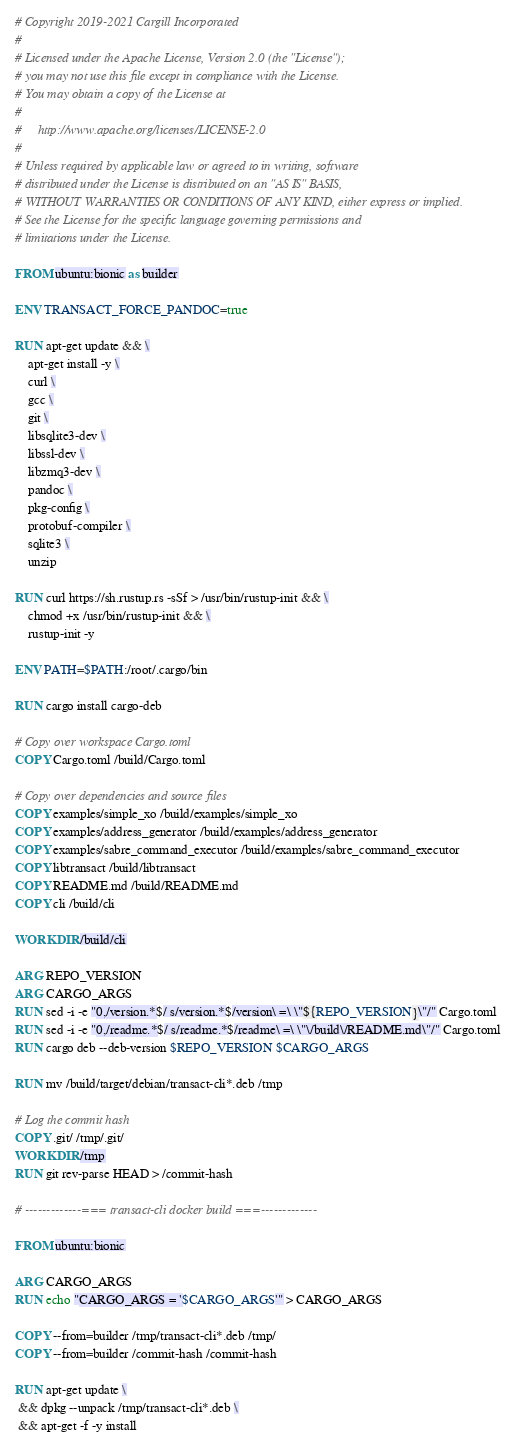<code> <loc_0><loc_0><loc_500><loc_500><_Dockerfile_># Copyright 2019-2021 Cargill Incorporated
#
# Licensed under the Apache License, Version 2.0 (the "License");
# you may not use this file except in compliance with the License.
# You may obtain a copy of the License at
#
#     http://www.apache.org/licenses/LICENSE-2.0
#
# Unless required by applicable law or agreed to in writing, software
# distributed under the License is distributed on an "AS IS" BASIS,
# WITHOUT WARRANTIES OR CONDITIONS OF ANY KIND, either express or implied.
# See the License for the specific language governing permissions and
# limitations under the License.

FROM ubuntu:bionic as builder

ENV TRANSACT_FORCE_PANDOC=true

RUN apt-get update && \
    apt-get install -y \
    curl \
    gcc \
    git \
    libsqlite3-dev \
    libssl-dev \
    libzmq3-dev \
    pandoc \
    pkg-config \
    protobuf-compiler \
    sqlite3 \
    unzip

RUN curl https://sh.rustup.rs -sSf > /usr/bin/rustup-init && \
    chmod +x /usr/bin/rustup-init && \
    rustup-init -y

ENV PATH=$PATH:/root/.cargo/bin

RUN cargo install cargo-deb

# Copy over workspace Cargo.toml
COPY Cargo.toml /build/Cargo.toml

# Copy over dependencies and source files
COPY examples/simple_xo /build/examples/simple_xo
COPY examples/address_generator /build/examples/address_generator
COPY examples/sabre_command_executor /build/examples/sabre_command_executor
COPY libtransact /build/libtransact
COPY README.md /build/README.md
COPY cli /build/cli

WORKDIR /build/cli

ARG REPO_VERSION
ARG CARGO_ARGS
RUN sed -i -e "0,/version.*$/ s/version.*$/version\ =\ \"${REPO_VERSION}\"/" Cargo.toml
RUN sed -i -e "0,/readme.*$/ s/readme.*$/readme\ =\ \"\/build\/README.md\"/" Cargo.toml
RUN cargo deb --deb-version $REPO_VERSION $CARGO_ARGS

RUN mv /build/target/debian/transact-cli*.deb /tmp

# Log the commit hash
COPY .git/ /tmp/.git/
WORKDIR /tmp
RUN git rev-parse HEAD > /commit-hash

# -------------=== transact-cli docker build ===-------------

FROM ubuntu:bionic

ARG CARGO_ARGS
RUN echo "CARGO_ARGS = '$CARGO_ARGS'" > CARGO_ARGS

COPY --from=builder /tmp/transact-cli*.deb /tmp/
COPY --from=builder /commit-hash /commit-hash

RUN apt-get update \
 && dpkg --unpack /tmp/transact-cli*.deb \
 && apt-get -f -y install
</code> 